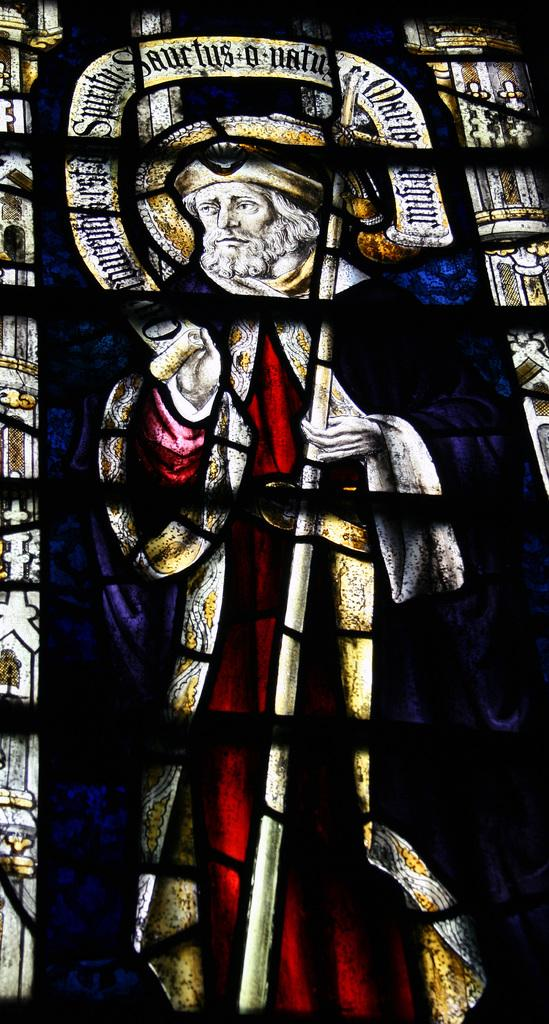What is the focus of the image? The image is zoomed in on a picture of a man. What is the man wearing in the image? The man is wearing a dress in the image. What is the man holding in the image? The man is holding a stick in the image. What is the man's posture in the image? The man appears to be standing in the image. What can be seen at the top of the image? There is text written at the top of the image. How many lizards can be seen crawling on the man's dress in the image? There are no lizards present in the image. What type of kitten is sitting on the man's shoulder in the image? There is no kitten present in the image. 